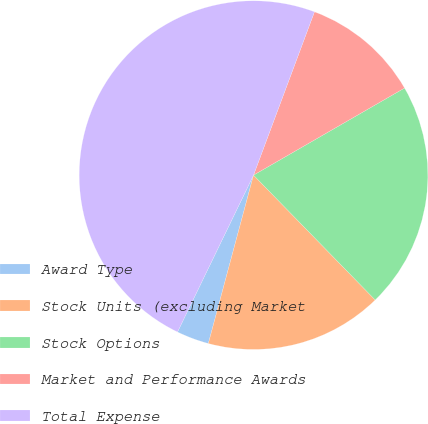Convert chart to OTSL. <chart><loc_0><loc_0><loc_500><loc_500><pie_chart><fcel>Award Type<fcel>Stock Units (excluding Market<fcel>Stock Options<fcel>Market and Performance Awards<fcel>Total Expense<nl><fcel>3.01%<fcel>16.47%<fcel>21.03%<fcel>10.99%<fcel>48.5%<nl></chart> 